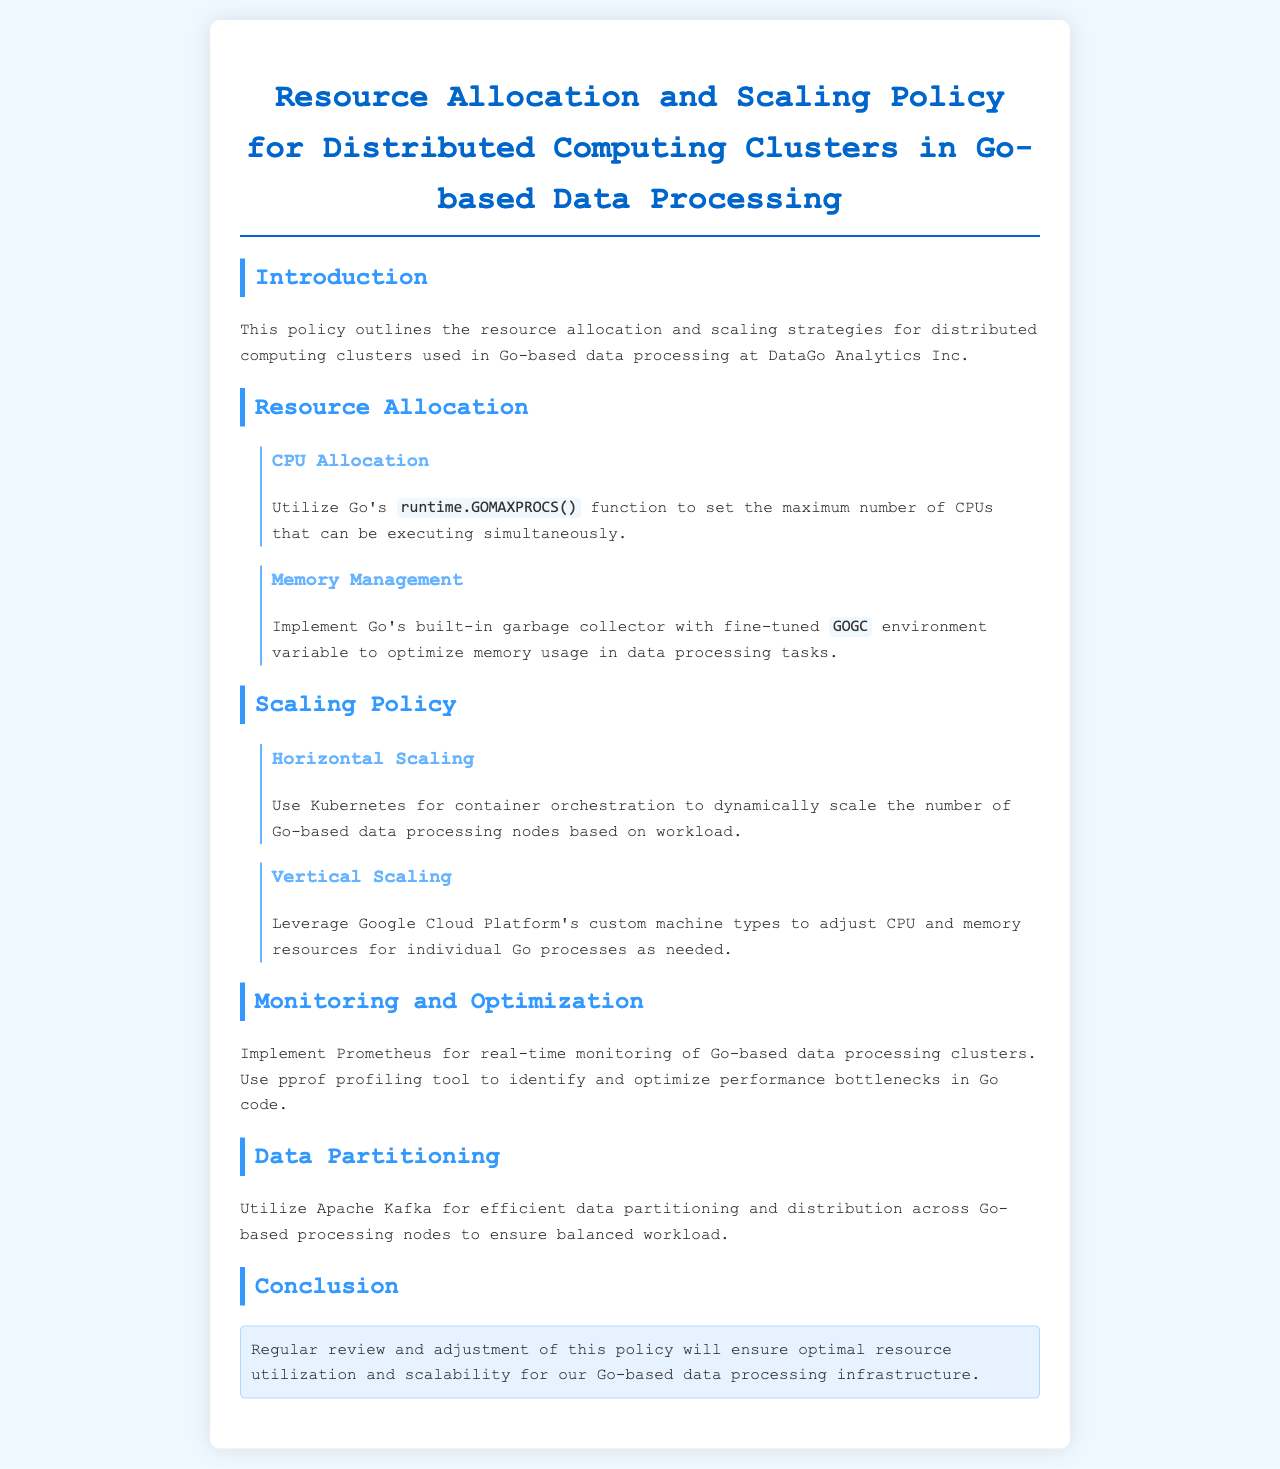What is the title of the policy document? The title outlines the main subject and focus of the document.
Answer: Resource Allocation and Scaling Policy for Distributed Computing Clusters in Go-based Data Processing Which function is suggested for CPU allocation? The document specifies a Go function related to setting CPU execution limits.
Answer: runtime.GOMAXPROCS() What environment variable is mentioned for memory management? The document mentions a specific variable that is adjusted to optimize memory usage in processes.
Answer: GOGC What container orchestration tool is recommended for horizontal scaling? The policy suggests a specific tool for managing containers and scaling them effectively.
Answer: Kubernetes Which cloud platform is used for vertical scaling adjustments? The document identifies a specific platform for modifying CPU and memory resources.
Answer: Google Cloud Platform What monitoring tool is recommended for real-time cluster monitoring? The document specifies a particular monitoring system that is implemented for oversight.
Answer: Prometheus What technology is suggested for efficient data partitioning? The policy outlines a tool used for data distribution across processing nodes.
Answer: Apache Kafka What should be regularly reviewed to ensure optimal resource utilization? The conclusion section mentions a practice necessary for maintaining effective resource use and scalability.
Answer: Policy 